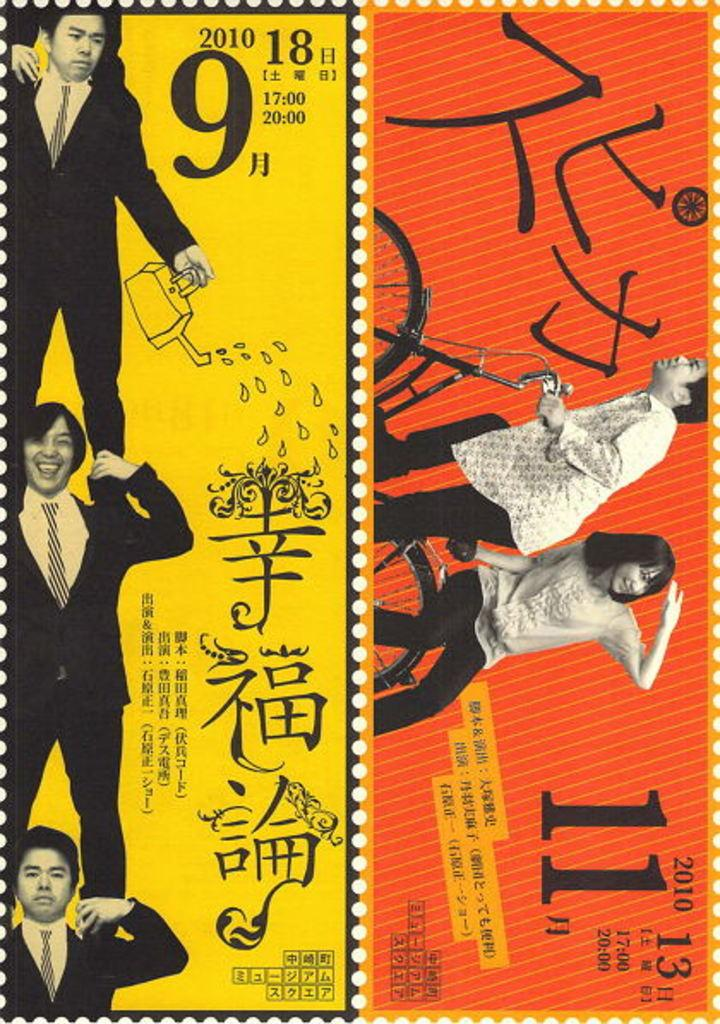<image>
Present a compact description of the photo's key features. Three men stand on top of each others shoulders with a large 9 next to the top one 